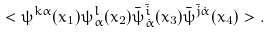<formula> <loc_0><loc_0><loc_500><loc_500>< \psi ^ { k \alpha } ( x _ { 1 } ) \psi ^ { l } _ { \alpha } ( x _ { 2 } ) { \bar { \psi } } ^ { \bar { i } } _ { \dot { \alpha } } ( x _ { 3 } ) { \bar { \psi } } ^ { { \bar { j } } \dot { \alpha } } ( x _ { 4 } ) > .</formula> 